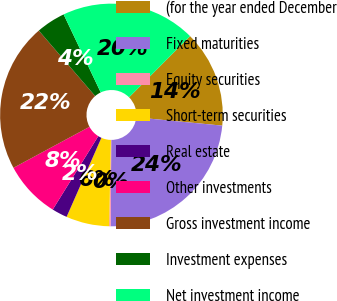Convert chart to OTSL. <chart><loc_0><loc_0><loc_500><loc_500><pie_chart><fcel>(for the year ended December<fcel>Fixed maturities<fcel>Equity securities<fcel>Short-term securities<fcel>Real estate<fcel>Other investments<fcel>Gross investment income<fcel>Investment expenses<fcel>Net investment income<nl><fcel>14.05%<fcel>23.58%<fcel>0.22%<fcel>6.27%<fcel>2.24%<fcel>8.29%<fcel>21.56%<fcel>4.25%<fcel>19.54%<nl></chart> 